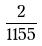<formula> <loc_0><loc_0><loc_500><loc_500>\frac { 2 } { 1 1 5 5 }</formula> 